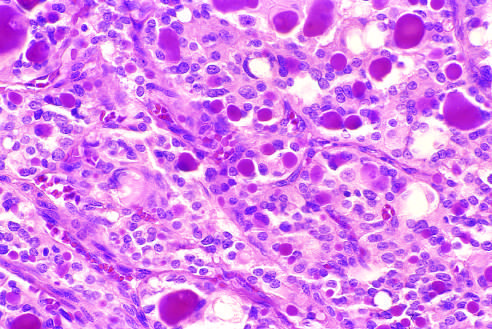do a few of the glandular lumina contain recognizable colloid?
Answer the question using a single word or phrase. Yes 